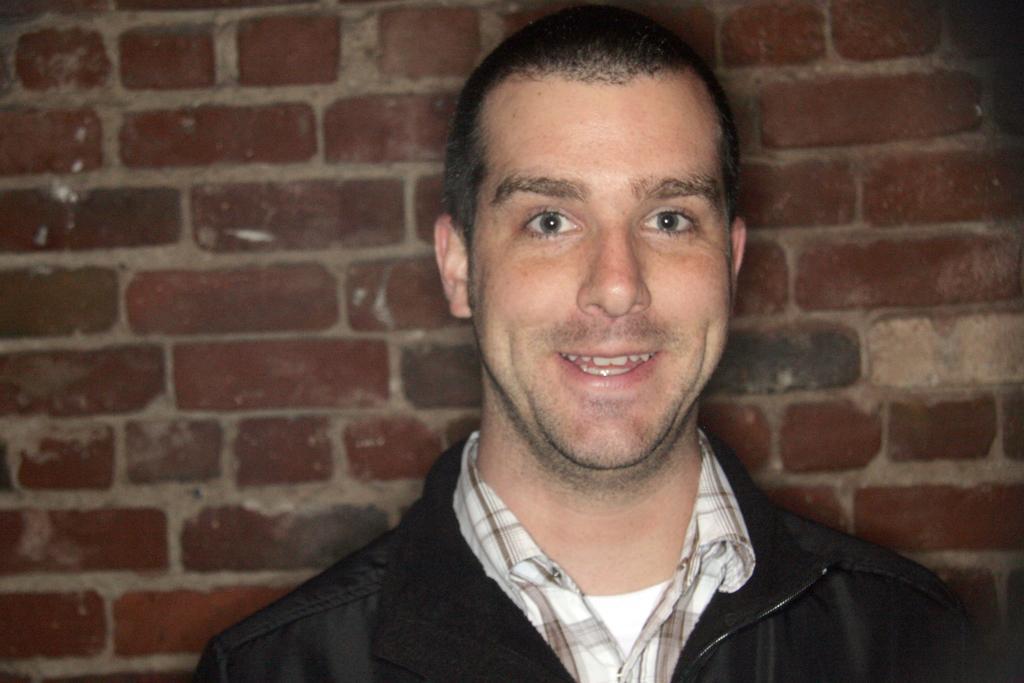How would you summarize this image in a sentence or two? In this picture we can see a man smiling and in the background we can see brick wall. 